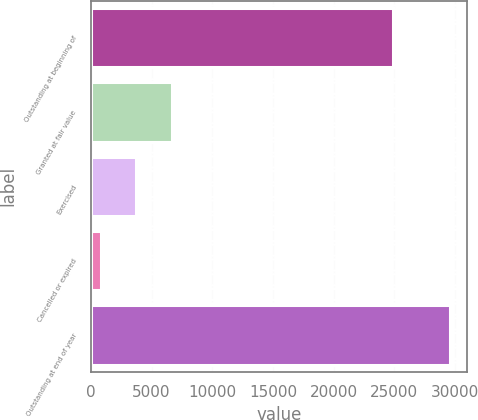<chart> <loc_0><loc_0><loc_500><loc_500><bar_chart><fcel>Outstanding at beginning of<fcel>Granted at fair value<fcel>Exercised<fcel>Cancelled or expired<fcel>Outstanding at end of year<nl><fcel>24843.5<fcel>6651.2<fcel>3726.87<fcel>858.5<fcel>29542.2<nl></chart> 